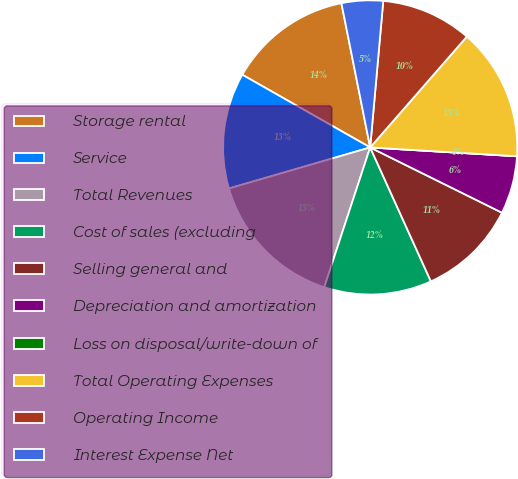Convert chart to OTSL. <chart><loc_0><loc_0><loc_500><loc_500><pie_chart><fcel>Storage rental<fcel>Service<fcel>Total Revenues<fcel>Cost of sales (excluding<fcel>Selling general and<fcel>Depreciation and amortization<fcel>Loss on disposal/write-down of<fcel>Total Operating Expenses<fcel>Operating Income<fcel>Interest Expense Net<nl><fcel>13.64%<fcel>12.73%<fcel>15.45%<fcel>11.82%<fcel>10.91%<fcel>6.36%<fcel>0.0%<fcel>14.54%<fcel>10.0%<fcel>4.55%<nl></chart> 